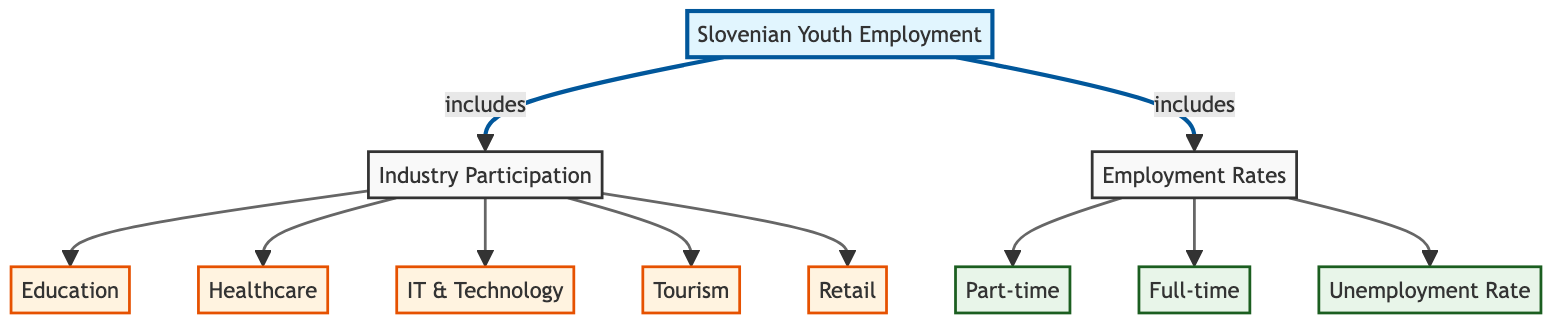What are the components included in Slovenian Youth Employment? The diagram indicates that Slovenian Youth Employment includes two major components: Industry Participation and Employment Rates. These components are shown as branches stemming from the main node.
Answer: Industry Participation and Employment Rates How many industries are represented under Industry Participation? The diagram displays five distinct industries under Industry Participation: Education, Healthcare, IT & Technology, Tourism, and Retail, which are effectively five separate nodes connected to the Industry Participation node.
Answer: Five What are the types of employment rates listed in the diagram? Under Employment Rates, there are three specified types: Part-time, Full-time, and Unemployment Rate. These employment rate categories are represented visually as separate nodes stemming from the Employment Rates node.
Answer: Part-time, Full-time, Unemployment Rate Which industry is connected to the highest participation rate in the diagram? The diagram does not provide explicit participation rates; however, it illustrates that all listed industries under Industry Participation are included equally and do not have defined hierarchical connections, so no specific industry can be identified as having the highest participation.
Answer: Not specified What connections are made from the Slovenian Youth Employment node? The Slovenian Youth Employment node connects directly to two nodes: Industry Participation and Employment Rates, making it clear that both components are primary aspects of the overall statistics for youth employment in Slovenia.
Answer: Industry Participation and Employment Rates Are there any nodes connected only to the Employment Rates? Yes, the nodes connected solely to Employment Rates are Part-time, Full-time, and Unemployment Rate, which indicates these employment metrics are specifically categorized under the Employment Rates component without branching back to Industry Participation.
Answer: Yes Which node does the Healthcare industry connect to? The Healthcare industry connects directly to the Industry Participation node, indicating it is one of the categories included under the broad aspect of youth employment in specific industries.
Answer: Industry Participation What can be inferred about the relationship between Industry Participation and Employment Rates in the diagram? The relationship inferred is that both components—Industry Participation and Employment Rates—are essential elements of Slovenian Youth Employment. They are parallel components that together contribute to a comprehensive understanding of youth employment statistics.
Answer: Essential components of youth employment 